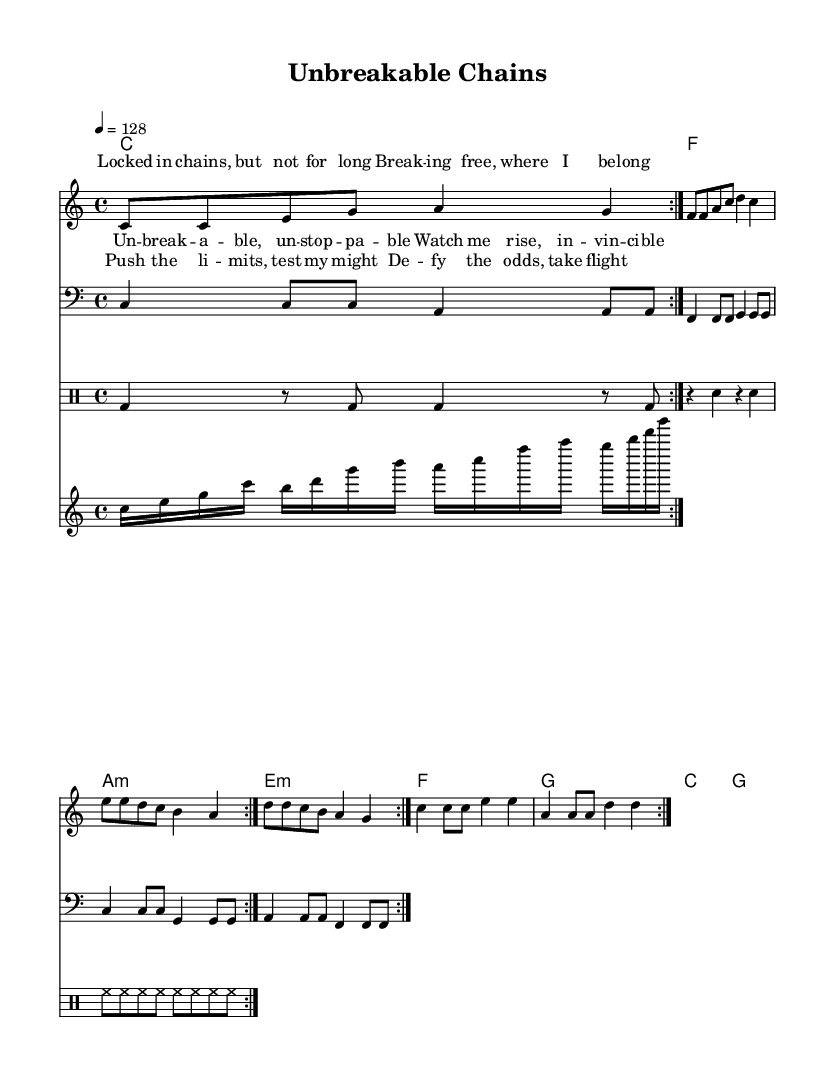What is the key signature of this music? The key signature is C major, which has no sharps or flats.
Answer: C major What is the time signature of this piece? The music is in 4/4 time, indicated at the beginning of the score.
Answer: 4/4 What is the tempo marking of the piece? The tempo is indicated as "4 = 128", meaning there are 128 beats per minute for quarter notes.
Answer: 128 How many measures are in the melody section? The melody section has a total of 16 measures, which are repeated once according to the repeat markings.
Answer: 16 What is the predominant genre of this music piece? The piece is an upbeat electro-pop anthem with a celebratory theme, evidenced by its driving rhythm and triumph-themed lyrics.
Answer: Electro-pop What do the lyrics "Unbreakable, unstoppable" represent in the song? These lyrics serve as the chorus, emphasizing the theme of resilience and perseverance against adversity, capturing the essence of triumph.
Answer: Resilience In what octave is the melody primarily written? The melody is primarily written in the soprano range, with notes starting around middle C in the treble clef.
Answer: Soprano 